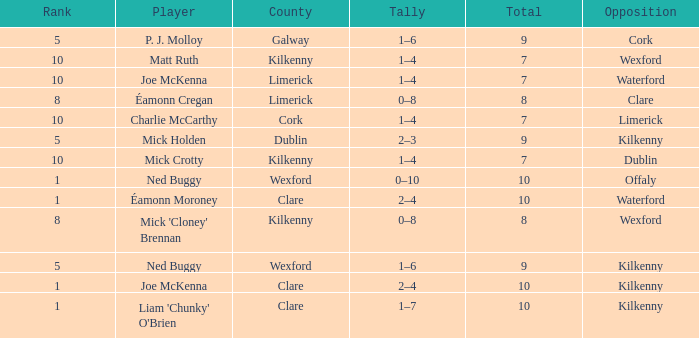What is galway county's total? 9.0. 